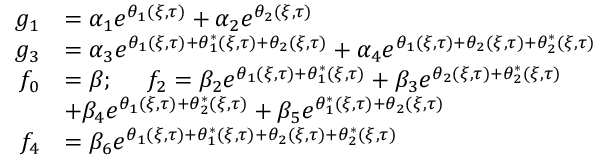Convert formula to latex. <formula><loc_0><loc_0><loc_500><loc_500>\begin{array} { r l } { g _ { 1 } } & { = \alpha _ { 1 } e ^ { \theta _ { 1 } ( \xi , \tau ) } + \alpha _ { 2 } e ^ { \theta _ { 2 } ( \xi , \tau ) } } \\ { g _ { 3 } } & { = \alpha _ { 3 } e ^ { \theta _ { 1 } ( \xi , \tau ) + \theta _ { 1 } ^ { * } ( \xi , \tau ) + \theta _ { 2 } ( \xi , \tau ) } + \alpha _ { 4 } e ^ { \theta _ { 1 } ( \xi , \tau ) + \theta _ { 2 } ( \xi , \tau ) + \theta _ { 2 } ^ { * } ( \xi , \tau ) } } \\ { f _ { 0 } } & { = \beta ; \quad \ f _ { 2 } = \beta _ { 2 } e ^ { \theta _ { 1 } ( \xi , \tau ) + \theta _ { 1 } ^ { * } ( \xi , \tau ) } + \beta _ { 3 } e ^ { \theta _ { 2 } ( \xi , \tau ) + \theta _ { 2 } ^ { * } ( \xi , \tau ) } } \\ & { + \beta _ { 4 } e ^ { \theta _ { 1 } ( \xi , \tau ) + \theta _ { 2 } ^ { * } ( \xi , \tau ) } + \beta _ { 5 } e ^ { \theta _ { 1 } ^ { * } ( \xi , \tau ) + \theta _ { 2 } ( \xi , \tau ) } } \\ { f _ { 4 } } & { = \beta _ { 6 } e ^ { \theta _ { 1 } ( \xi , \tau ) + \theta _ { 1 } ^ { * } ( \xi , \tau ) + \theta _ { 2 } ( \xi , \tau ) + \theta _ { 2 } ^ { * } ( \xi , \tau ) } } \end{array}</formula> 